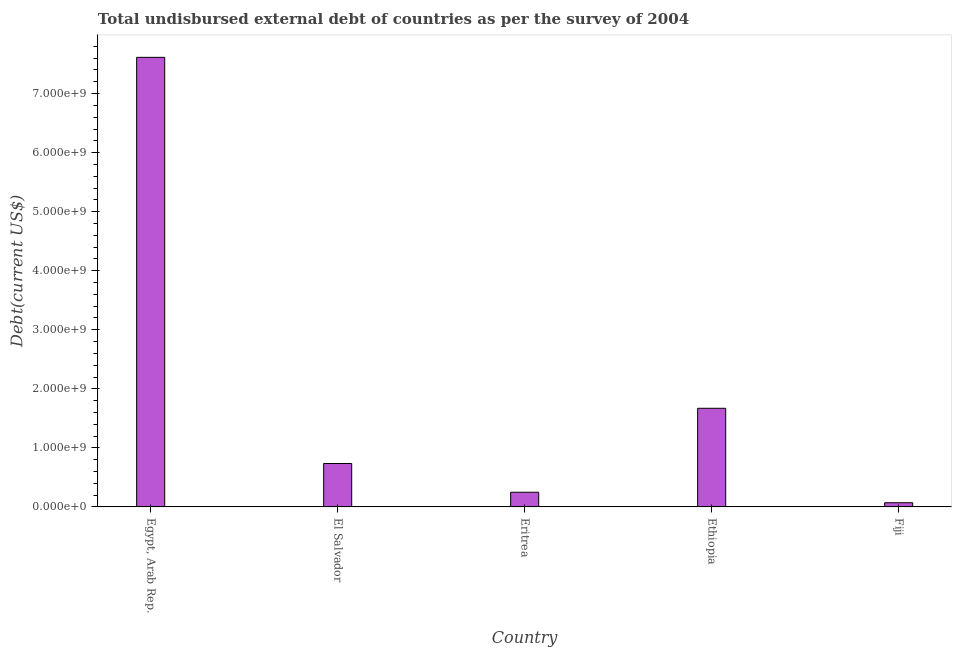What is the title of the graph?
Your answer should be very brief. Total undisbursed external debt of countries as per the survey of 2004. What is the label or title of the X-axis?
Give a very brief answer. Country. What is the label or title of the Y-axis?
Ensure brevity in your answer.  Debt(current US$). What is the total debt in Eritrea?
Offer a very short reply. 2.49e+08. Across all countries, what is the maximum total debt?
Your answer should be very brief. 7.61e+09. Across all countries, what is the minimum total debt?
Make the answer very short. 7.10e+07. In which country was the total debt maximum?
Provide a succinct answer. Egypt, Arab Rep. In which country was the total debt minimum?
Keep it short and to the point. Fiji. What is the sum of the total debt?
Your answer should be compact. 1.03e+1. What is the difference between the total debt in El Salvador and Ethiopia?
Make the answer very short. -9.35e+08. What is the average total debt per country?
Ensure brevity in your answer.  2.07e+09. What is the median total debt?
Offer a very short reply. 7.35e+08. In how many countries, is the total debt greater than 7000000000 US$?
Ensure brevity in your answer.  1. What is the ratio of the total debt in El Salvador to that in Ethiopia?
Offer a very short reply. 0.44. Is the total debt in El Salvador less than that in Fiji?
Keep it short and to the point. No. Is the difference between the total debt in El Salvador and Ethiopia greater than the difference between any two countries?
Your answer should be very brief. No. What is the difference between the highest and the second highest total debt?
Your response must be concise. 5.94e+09. Is the sum of the total debt in Egypt, Arab Rep. and El Salvador greater than the maximum total debt across all countries?
Make the answer very short. Yes. What is the difference between the highest and the lowest total debt?
Offer a terse response. 7.54e+09. Are the values on the major ticks of Y-axis written in scientific E-notation?
Provide a succinct answer. Yes. What is the Debt(current US$) in Egypt, Arab Rep.?
Your answer should be very brief. 7.61e+09. What is the Debt(current US$) in El Salvador?
Give a very brief answer. 7.35e+08. What is the Debt(current US$) in Eritrea?
Offer a terse response. 2.49e+08. What is the Debt(current US$) of Ethiopia?
Make the answer very short. 1.67e+09. What is the Debt(current US$) of Fiji?
Ensure brevity in your answer.  7.10e+07. What is the difference between the Debt(current US$) in Egypt, Arab Rep. and El Salvador?
Ensure brevity in your answer.  6.88e+09. What is the difference between the Debt(current US$) in Egypt, Arab Rep. and Eritrea?
Your answer should be compact. 7.36e+09. What is the difference between the Debt(current US$) in Egypt, Arab Rep. and Ethiopia?
Give a very brief answer. 5.94e+09. What is the difference between the Debt(current US$) in Egypt, Arab Rep. and Fiji?
Give a very brief answer. 7.54e+09. What is the difference between the Debt(current US$) in El Salvador and Eritrea?
Offer a very short reply. 4.87e+08. What is the difference between the Debt(current US$) in El Salvador and Ethiopia?
Ensure brevity in your answer.  -9.35e+08. What is the difference between the Debt(current US$) in El Salvador and Fiji?
Provide a succinct answer. 6.64e+08. What is the difference between the Debt(current US$) in Eritrea and Ethiopia?
Provide a short and direct response. -1.42e+09. What is the difference between the Debt(current US$) in Eritrea and Fiji?
Make the answer very short. 1.78e+08. What is the difference between the Debt(current US$) in Ethiopia and Fiji?
Your response must be concise. 1.60e+09. What is the ratio of the Debt(current US$) in Egypt, Arab Rep. to that in El Salvador?
Give a very brief answer. 10.35. What is the ratio of the Debt(current US$) in Egypt, Arab Rep. to that in Eritrea?
Ensure brevity in your answer.  30.59. What is the ratio of the Debt(current US$) in Egypt, Arab Rep. to that in Ethiopia?
Provide a short and direct response. 4.56. What is the ratio of the Debt(current US$) in Egypt, Arab Rep. to that in Fiji?
Make the answer very short. 107.2. What is the ratio of the Debt(current US$) in El Salvador to that in Eritrea?
Make the answer very short. 2.96. What is the ratio of the Debt(current US$) in El Salvador to that in Ethiopia?
Offer a very short reply. 0.44. What is the ratio of the Debt(current US$) in El Salvador to that in Fiji?
Give a very brief answer. 10.36. What is the ratio of the Debt(current US$) in Eritrea to that in Ethiopia?
Give a very brief answer. 0.15. What is the ratio of the Debt(current US$) in Eritrea to that in Fiji?
Give a very brief answer. 3.5. What is the ratio of the Debt(current US$) in Ethiopia to that in Fiji?
Your answer should be compact. 23.52. 